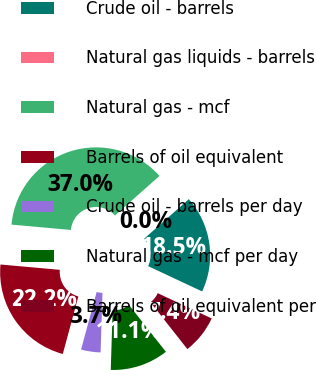Convert chart to OTSL. <chart><loc_0><loc_0><loc_500><loc_500><pie_chart><fcel>Crude oil - barrels<fcel>Natural gas liquids - barrels<fcel>Natural gas - mcf<fcel>Barrels of oil equivalent<fcel>Crude oil - barrels per day<fcel>Natural gas - mcf per day<fcel>Barrels of oil equivalent per<nl><fcel>18.52%<fcel>0.0%<fcel>37.03%<fcel>22.22%<fcel>3.71%<fcel>11.11%<fcel>7.41%<nl></chart> 